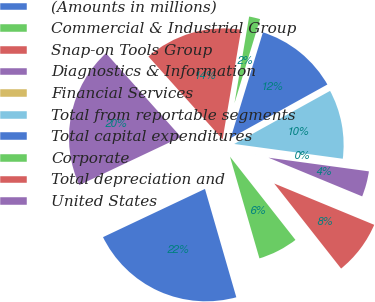Convert chart. <chart><loc_0><loc_0><loc_500><loc_500><pie_chart><fcel>(Amounts in millions)<fcel>Commercial & Industrial Group<fcel>Snap-on Tools Group<fcel>Diagnostics & Information<fcel>Financial Services<fcel>Total from reportable segments<fcel>Total capital expenditures<fcel>Corporate<fcel>Total depreciation and<fcel>United States<nl><fcel>22.45%<fcel>6.12%<fcel>8.16%<fcel>4.08%<fcel>0.0%<fcel>10.2%<fcel>12.24%<fcel>2.04%<fcel>14.28%<fcel>20.41%<nl></chart> 